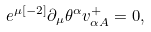Convert formula to latex. <formula><loc_0><loc_0><loc_500><loc_500>e ^ { \mu { [ - 2 ] } } \partial _ { \mu } \theta ^ { \alpha } v _ { \alpha { A } } ^ { + } = 0 ,</formula> 